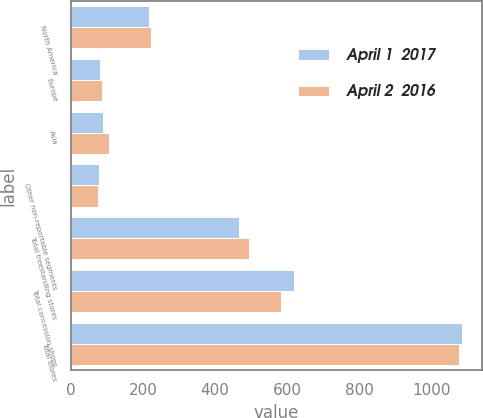Convert chart. <chart><loc_0><loc_0><loc_500><loc_500><stacked_bar_chart><ecel><fcel>North America<fcel>Europe<fcel>Asia<fcel>Other non-reportable segments<fcel>Total freestanding stores<fcel>Total concession shops<fcel>Total stores<nl><fcel>April 1  2017<fcel>216<fcel>82<fcel>89<fcel>79<fcel>466<fcel>619<fcel>1085<nl><fcel>April 2  2016<fcel>224<fcel>87<fcel>105<fcel>77<fcel>493<fcel>583<fcel>1076<nl></chart> 